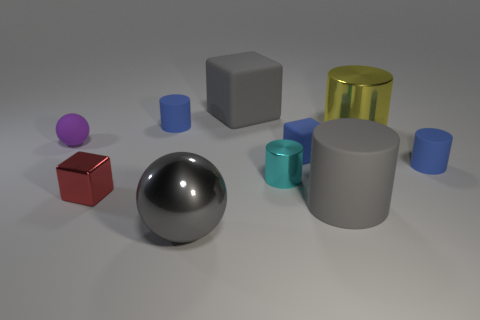Subtract all big gray rubber cylinders. How many cylinders are left? 4 Subtract 1 blocks. How many blocks are left? 2 Subtract all yellow cylinders. How many cylinders are left? 4 Subtract all purple cylinders. Subtract all blue blocks. How many cylinders are left? 5 Subtract all cubes. How many objects are left? 7 Add 8 tiny matte spheres. How many tiny matte spheres exist? 9 Subtract 2 blue cylinders. How many objects are left? 8 Subtract all yellow metallic things. Subtract all blocks. How many objects are left? 6 Add 9 tiny spheres. How many tiny spheres are left? 10 